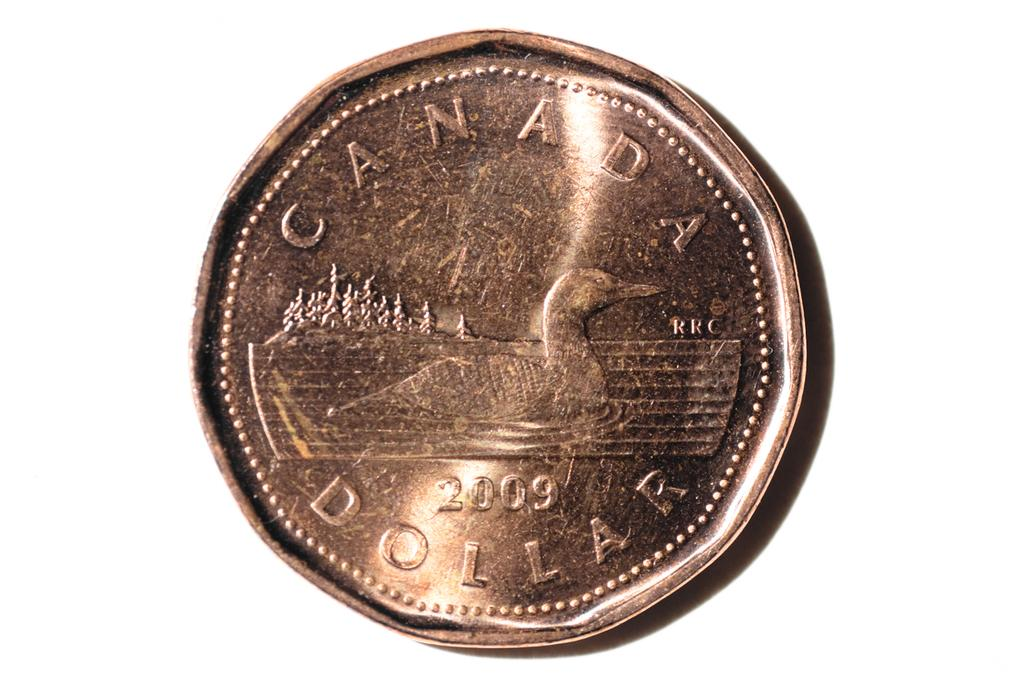<image>
Share a concise interpretation of the image provided. a golden 2009 coin that says 'canada dollar' on it 